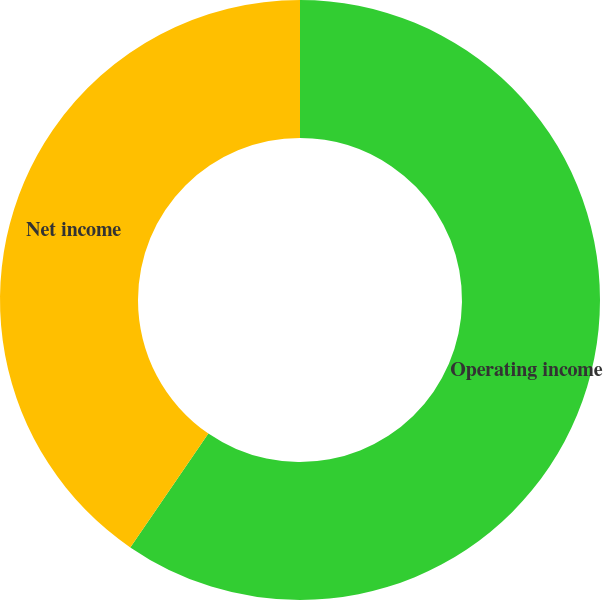<chart> <loc_0><loc_0><loc_500><loc_500><pie_chart><fcel>Operating income<fcel>Net income<nl><fcel>59.57%<fcel>40.43%<nl></chart> 